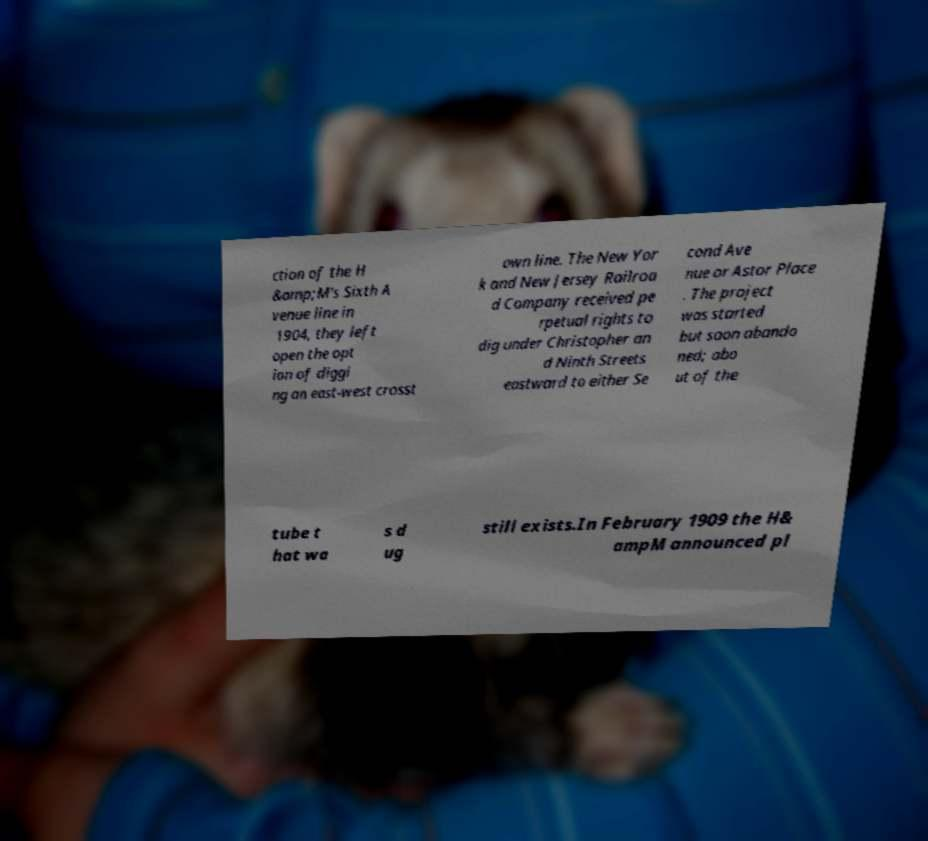For documentation purposes, I need the text within this image transcribed. Could you provide that? ction of the H &amp;M's Sixth A venue line in 1904, they left open the opt ion of diggi ng an east-west crosst own line. The New Yor k and New Jersey Railroa d Company received pe rpetual rights to dig under Christopher an d Ninth Streets eastward to either Se cond Ave nue or Astor Place . The project was started but soon abando ned; abo ut of the tube t hat wa s d ug still exists.In February 1909 the H& ampM announced pl 